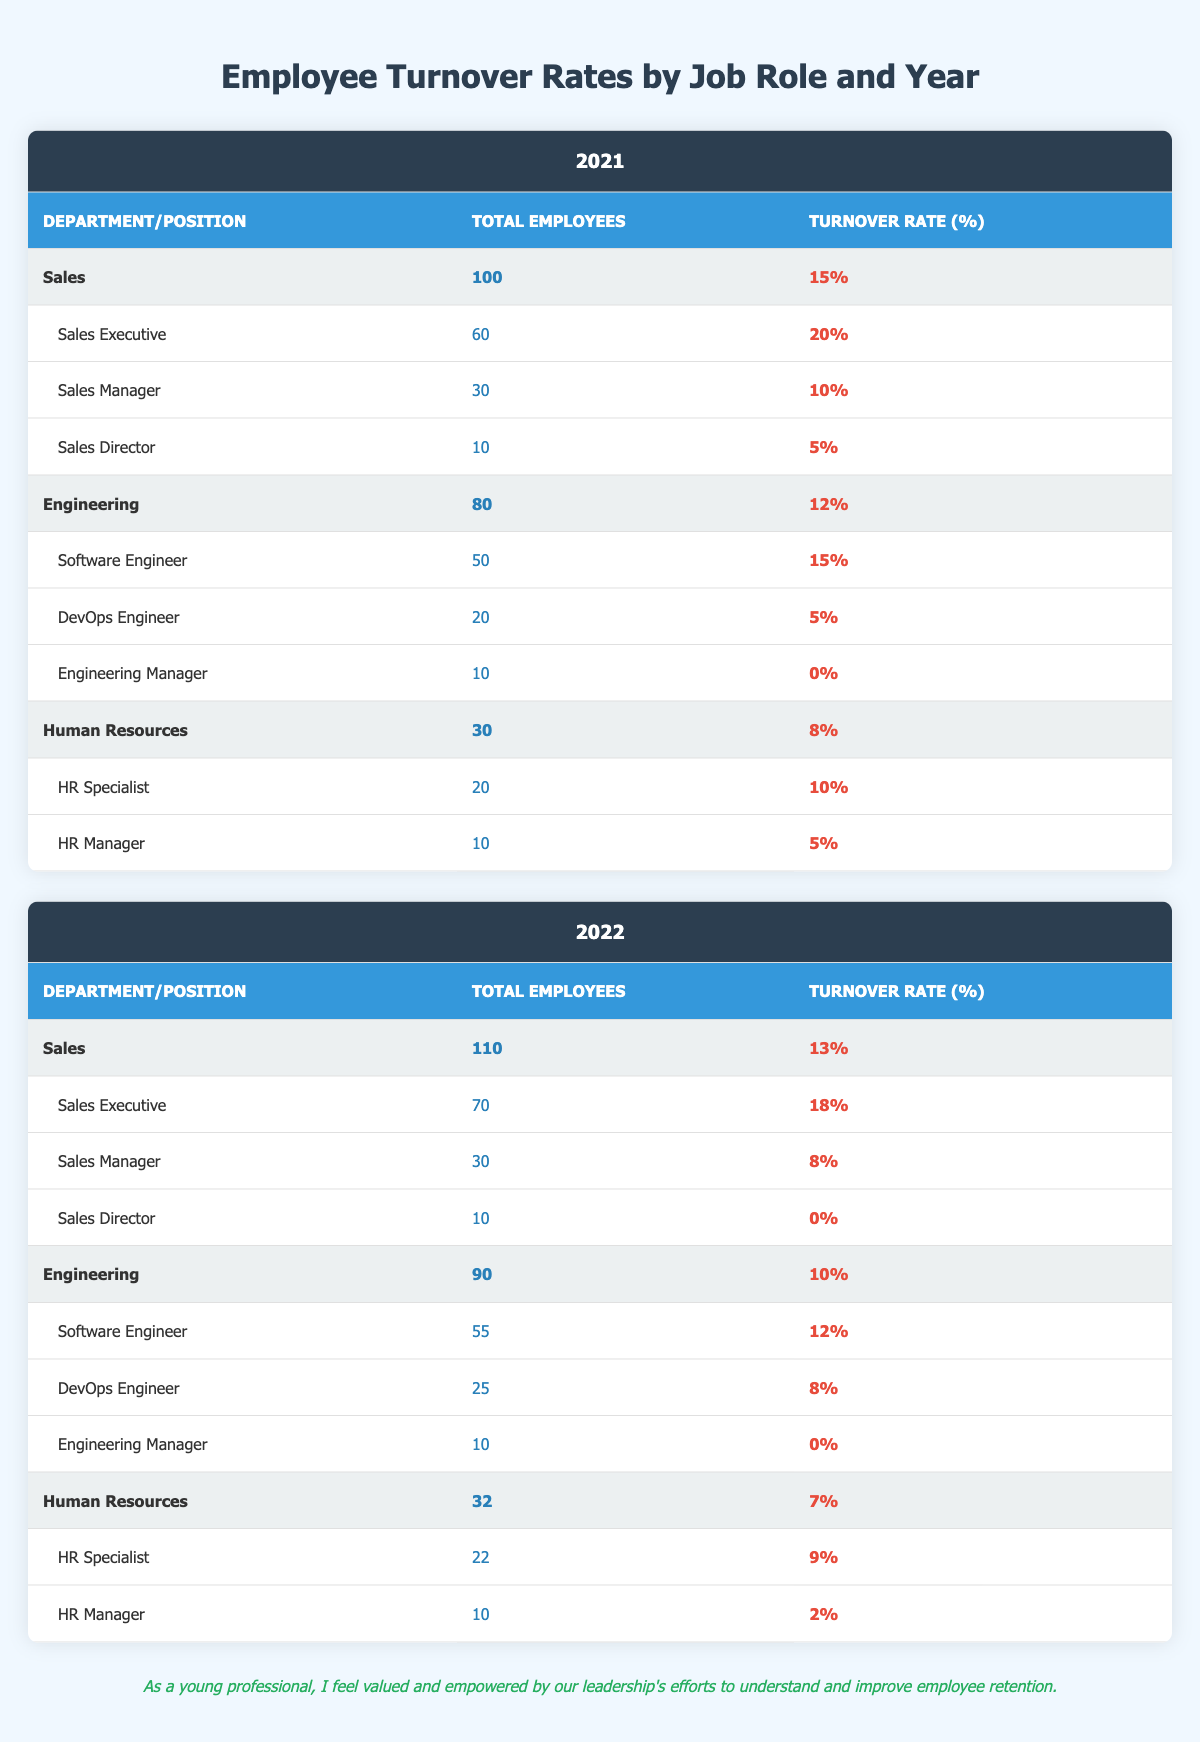What was the turnover rate for Sales in 2021? The table shows that the turnover rate for the Sales department in 2021 is listed directly, which is 15%.
Answer: 15% How many total employees were in Human Resources in 2022? Referring to the table, the total number of employees in the Human Resources department for the year 2022 is stated as 32.
Answer: 32 What is the turnover rate for Software Engineers in 2021? The turnover rate for Software Engineers can be found under the Engineering department for the year 2021, which is 15%.
Answer: 15% Which department had the highest turnover rate in 2022? To find the highest turnover rate, the rates for each department in 2022 must be compared: Sales (13%), Engineering (10%), and Human Resources (7%). The highest is Sales with a 13% rate.
Answer: Sales What is the difference in turnover rate for HR Managers between 2021 and 2022? The turnover rate for HR Managers is 5% in 2021 and reduces to 2% in 2022. The difference is calculated by subtracting the 2022 rate from the 2021 rate: 5% - 2% = 3%.
Answer: 3% Is it true that the turnover rate for Engineering Managers is zero in both years? Checking the table, the turnover rate for Engineering Managers is indeed 0% for both 2021 and 2022, confirming the statement as true.
Answer: Yes What was the average turnover rate for all positions in the Sales department in 2021? In 2021, the turnover rates for Sales positions are 20% (Sales Executive), 10% (Sales Manager), and 5% (Sales Director). The average is calculated as (20 + 10 + 5) / 3 = 35 / 3 = 11.67%.
Answer: 11.67% How many total employees in Engineering had a turnover rate above 10% in 2021? In Engineering for 2021, only the Software Engineer position had a turnover rate above 10% (15%), while the DevOps Engineer (5%) and Engineering Manager (0%) did not. Thus, there were 50 Software Engineers contributing to a turnover above 10%.
Answer: 50 What was the total turnover rate across all departments for the year 2021? To find the total turnover rate for 2021, the total number of employees and turnover contributions from each department must be included. Summing rates weighted by total employees: (100 * 15% + 80 * 12% + 30 * 8%) / (100 + 80 + 30) = (15 + 9.6 + 2.4) / 210 = 27 / 210 = 12.86%.
Answer: 12.86% 